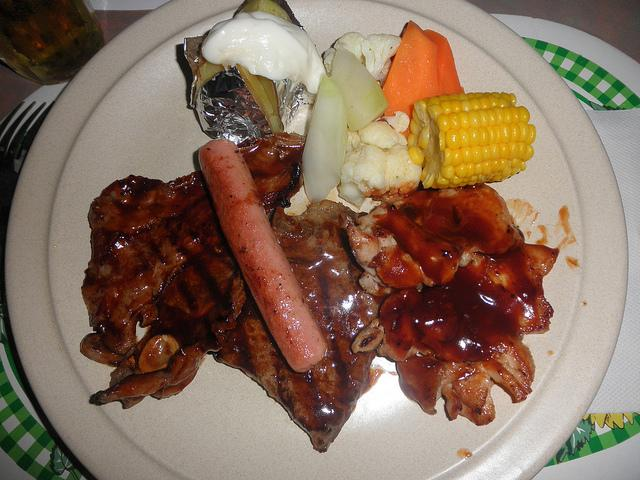Which dairy product is most prominent here?

Choices:
A) cottage cheese
B) sour cream
C) cheese
D) milk sour cream 